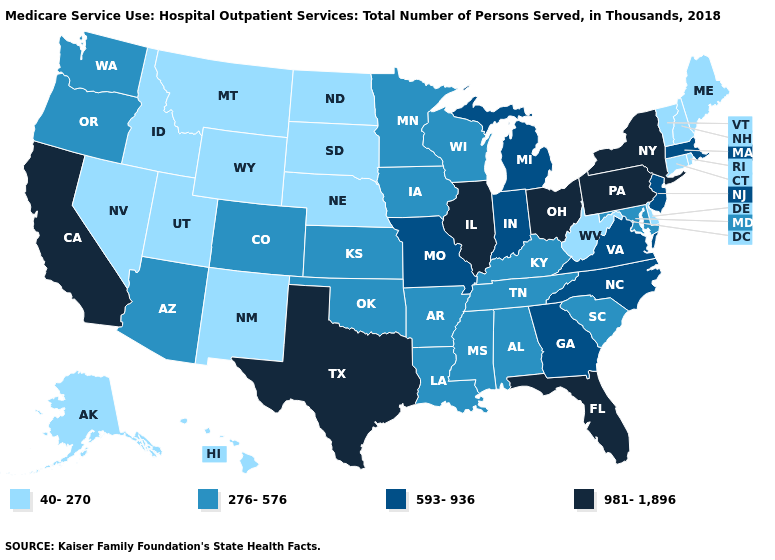How many symbols are there in the legend?
Quick response, please. 4. What is the value of Nevada?
Short answer required. 40-270. Among the states that border New Jersey , which have the lowest value?
Give a very brief answer. Delaware. Among the states that border Massachusetts , does Connecticut have the highest value?
Be succinct. No. Does Wyoming have the lowest value in the West?
Concise answer only. Yes. How many symbols are there in the legend?
Give a very brief answer. 4. What is the value of Massachusetts?
Answer briefly. 593-936. What is the value of Maine?
Concise answer only. 40-270. Among the states that border Minnesota , does North Dakota have the lowest value?
Quick response, please. Yes. What is the lowest value in the USA?
Answer briefly. 40-270. Does Florida have the same value as Kansas?
Answer briefly. No. Name the states that have a value in the range 276-576?
Concise answer only. Alabama, Arizona, Arkansas, Colorado, Iowa, Kansas, Kentucky, Louisiana, Maryland, Minnesota, Mississippi, Oklahoma, Oregon, South Carolina, Tennessee, Washington, Wisconsin. Which states have the highest value in the USA?
Short answer required. California, Florida, Illinois, New York, Ohio, Pennsylvania, Texas. Is the legend a continuous bar?
Keep it brief. No. Name the states that have a value in the range 276-576?
Concise answer only. Alabama, Arizona, Arkansas, Colorado, Iowa, Kansas, Kentucky, Louisiana, Maryland, Minnesota, Mississippi, Oklahoma, Oregon, South Carolina, Tennessee, Washington, Wisconsin. 